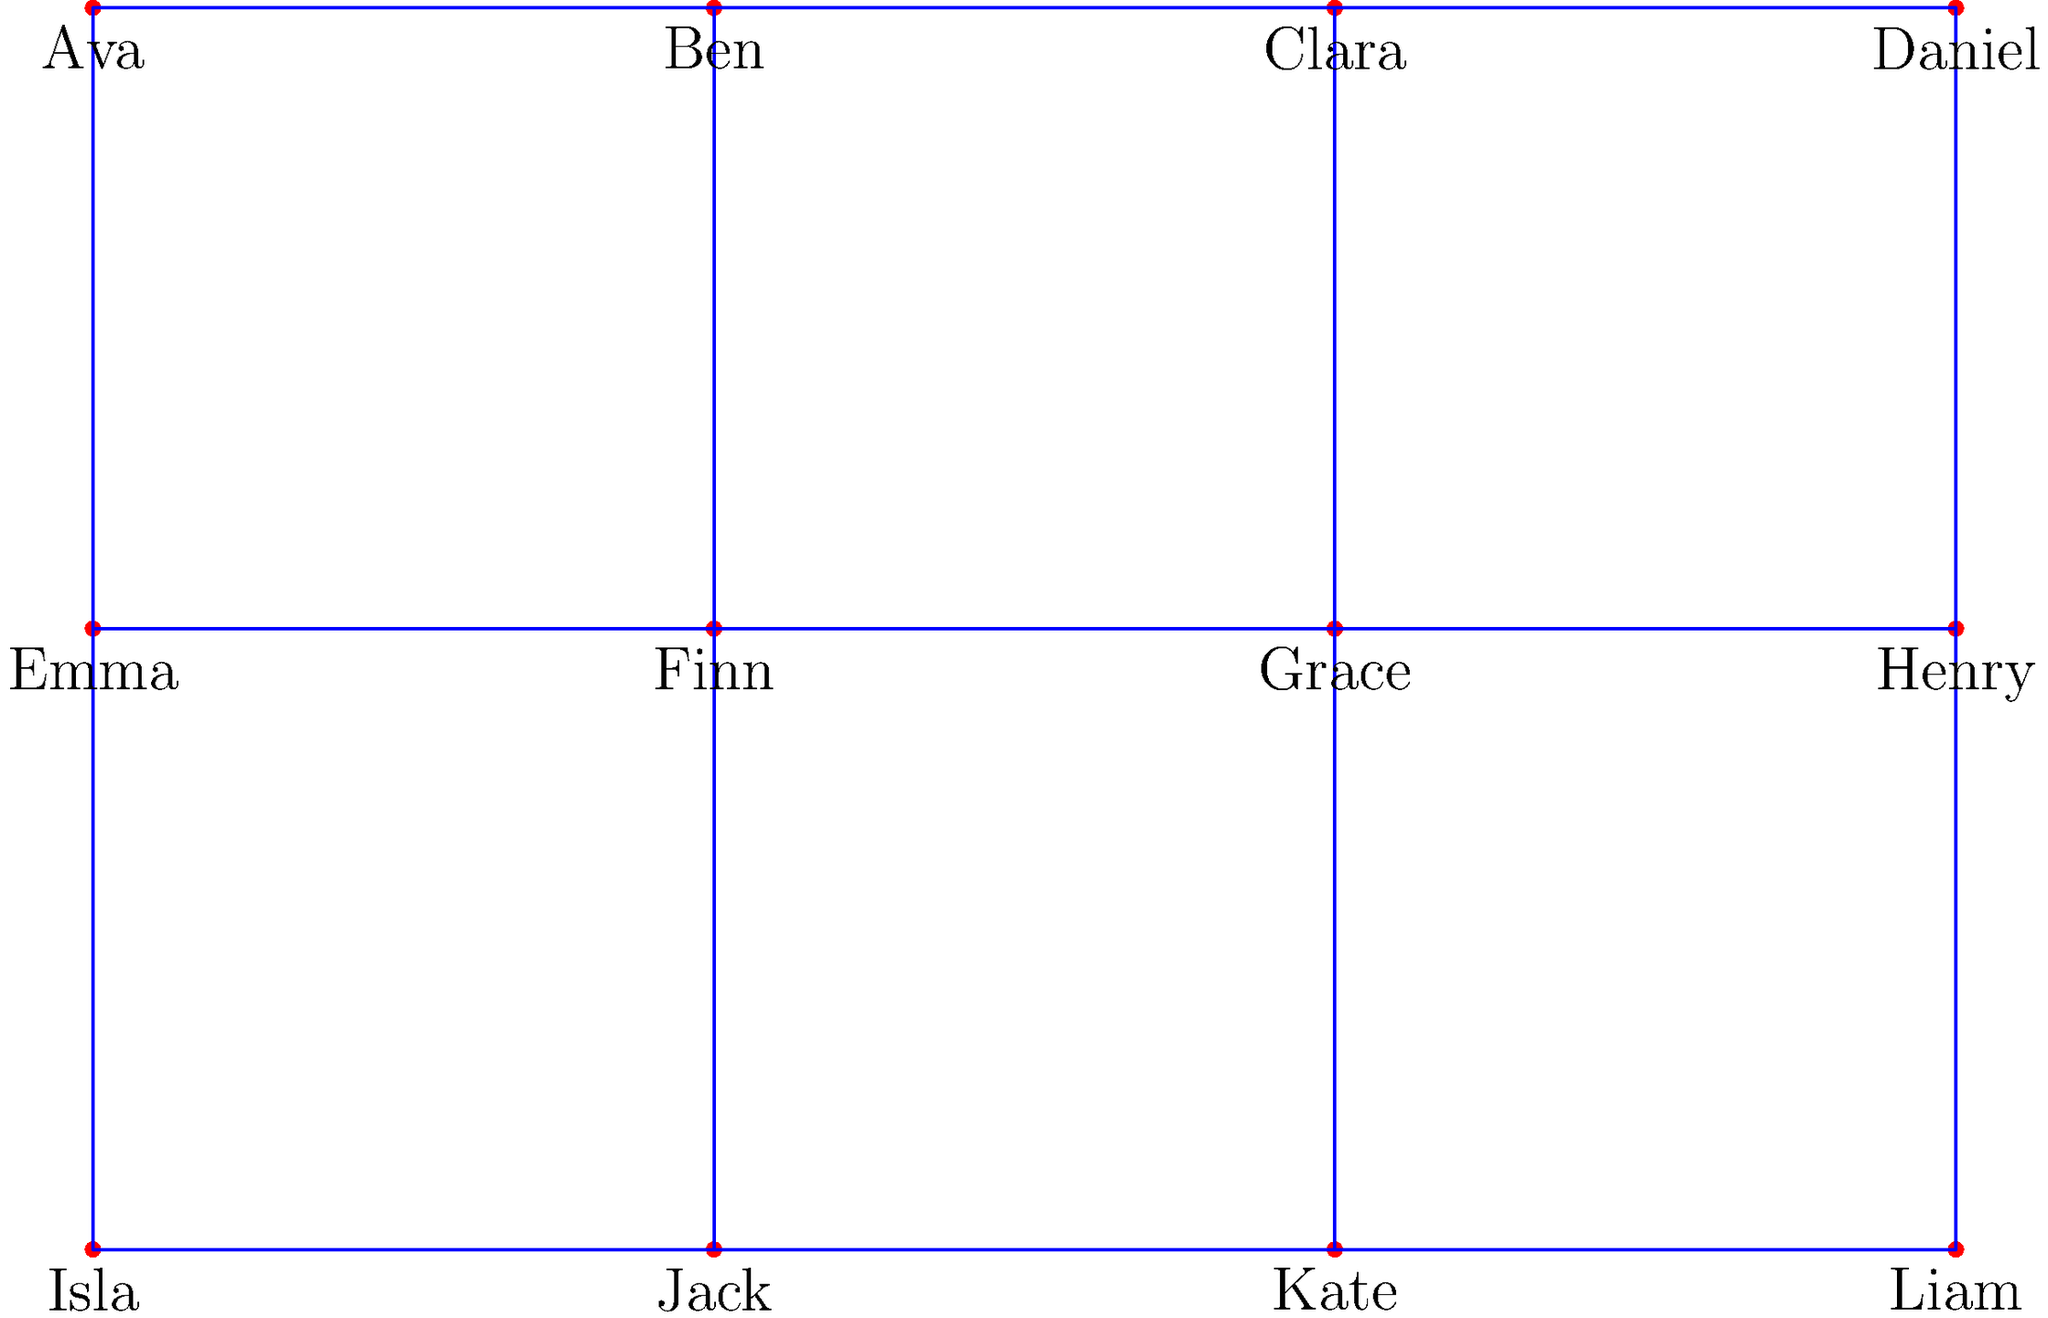In this complex family tree from a multi-generational saga, who are the two individuals that share a great-grandparent but are not directly related to each other as siblings or cousins? To answer this question, we need to analyze the family tree step by step:

1. The tree has three generations:
   - Top row: Ava, Ben, Clara, Daniel (1st generation)
   - Middle row: Emma, Finn, Grace, Henry (2nd generation)
   - Bottom row: Isla, Jack, Kate, Liam (3rd generation)

2. We need to identify individuals who share a great-grandparent:
   - All members of the 3rd generation share at least one great-grandparent from the 1st generation.

3. We should exclude direct siblings and cousins:
   - Siblings: Isla & Jack, Jack & Kate, Kate & Liam
   - First cousins: Isla & Jack, Jack & Kate, Kate & Liam (children of siblings)

4. The remaining relationships to consider are between:
   - Isla and Kate
   - Isla and Liam
   - Jack and Liam

5. Among these, Isla and Liam fit the criteria:
   - They share Ava as a great-grandparent
   - They are not siblings
   - They are not first cousins (their parents are not siblings)

Therefore, Isla and Liam are the two individuals who share a great-grandparent but are not directly related as siblings or cousins.
Answer: Isla and Liam 